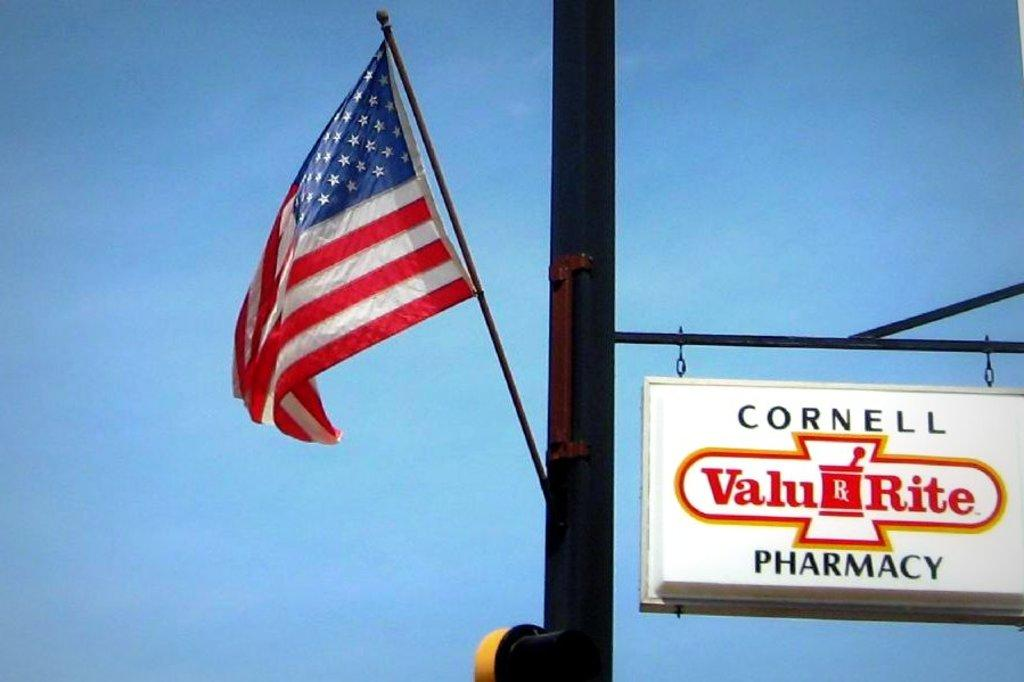What is the main subject in the center of the image? There is a flag in the center of the image. What is the flag attached to? The flag is attached to a pole in the image. What else can be seen in the image besides the flag and pole? There is an advertisement board in the image. What type of hair can be seen on the fish in the image? There is no fish or hair present in the image; it features a flag and a pole with an advertisement board. 